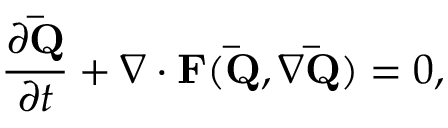<formula> <loc_0><loc_0><loc_500><loc_500>\frac { \partial \bar { Q } } { \partial t } + \nabla \cdot F ( \bar { Q } , \nabla \bar { Q } ) = 0 ,</formula> 